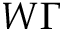<formula> <loc_0><loc_0><loc_500><loc_500>W \Gamma</formula> 